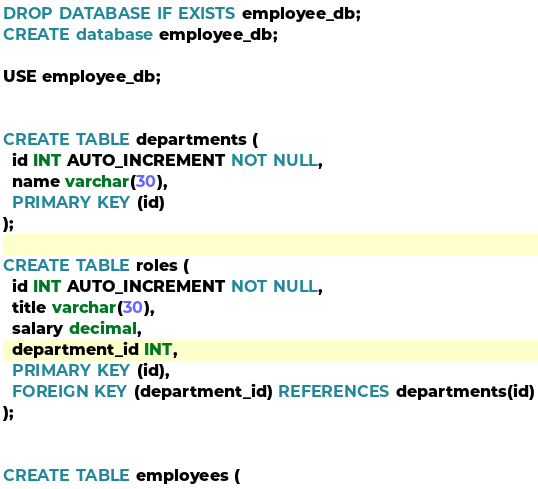<code> <loc_0><loc_0><loc_500><loc_500><_SQL_>DROP DATABASE IF EXISTS employee_db;
CREATE database employee_db;

USE employee_db;


CREATE TABLE departments (
  id INT AUTO_INCREMENT NOT NULL,
  name varchar(30),
  PRIMARY KEY (id)
);

CREATE TABLE roles (
  id INT AUTO_INCREMENT NOT NULL,
  title varchar(30),
  salary decimal,
  department_id INT,
  PRIMARY KEY (id),
  FOREIGN KEY (department_id) REFERENCES departments(id)
);


CREATE TABLE employees (</code> 